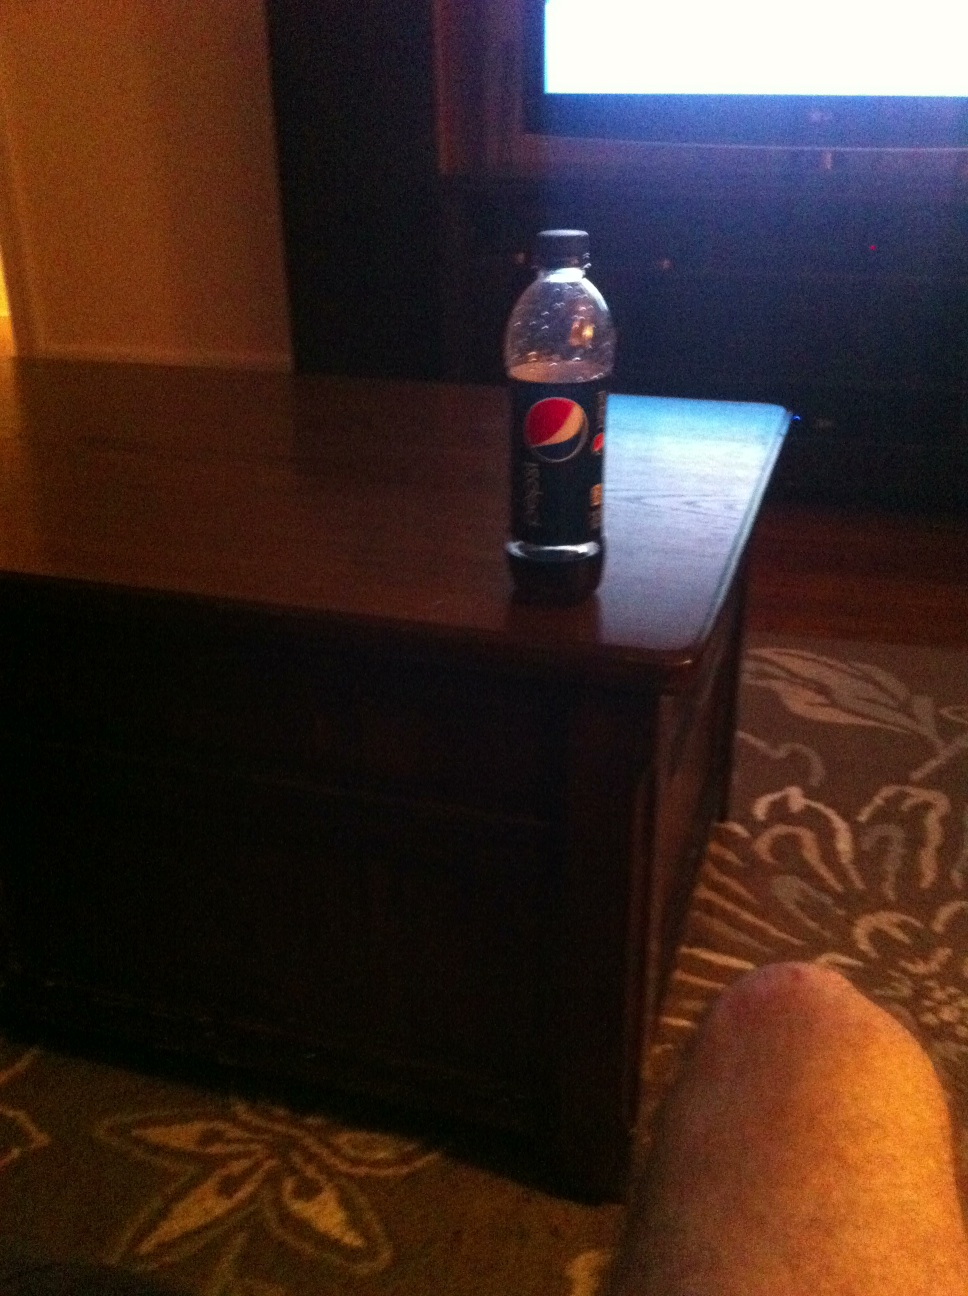Can you describe the setting in which this bottle is placed? The bottle of Pepsi is placed on a dark wooden coffee table, likely in a living room. The background features part of a television screen and a patterned rug, which suggests a home environment perfect for leisure or watching TV. 